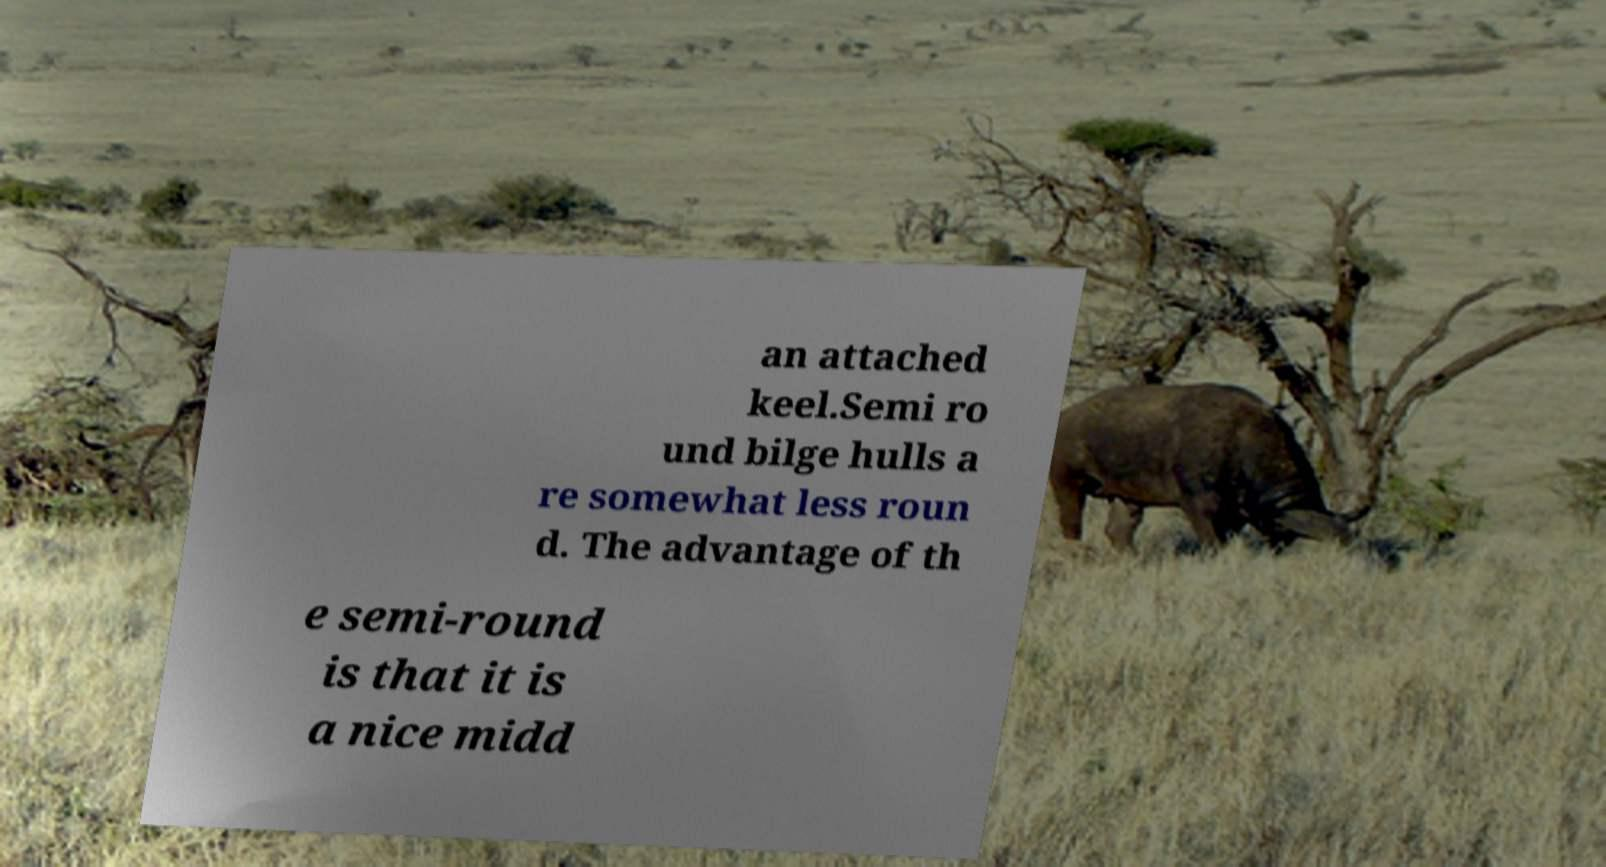There's text embedded in this image that I need extracted. Can you transcribe it verbatim? an attached keel.Semi ro und bilge hulls a re somewhat less roun d. The advantage of th e semi-round is that it is a nice midd 